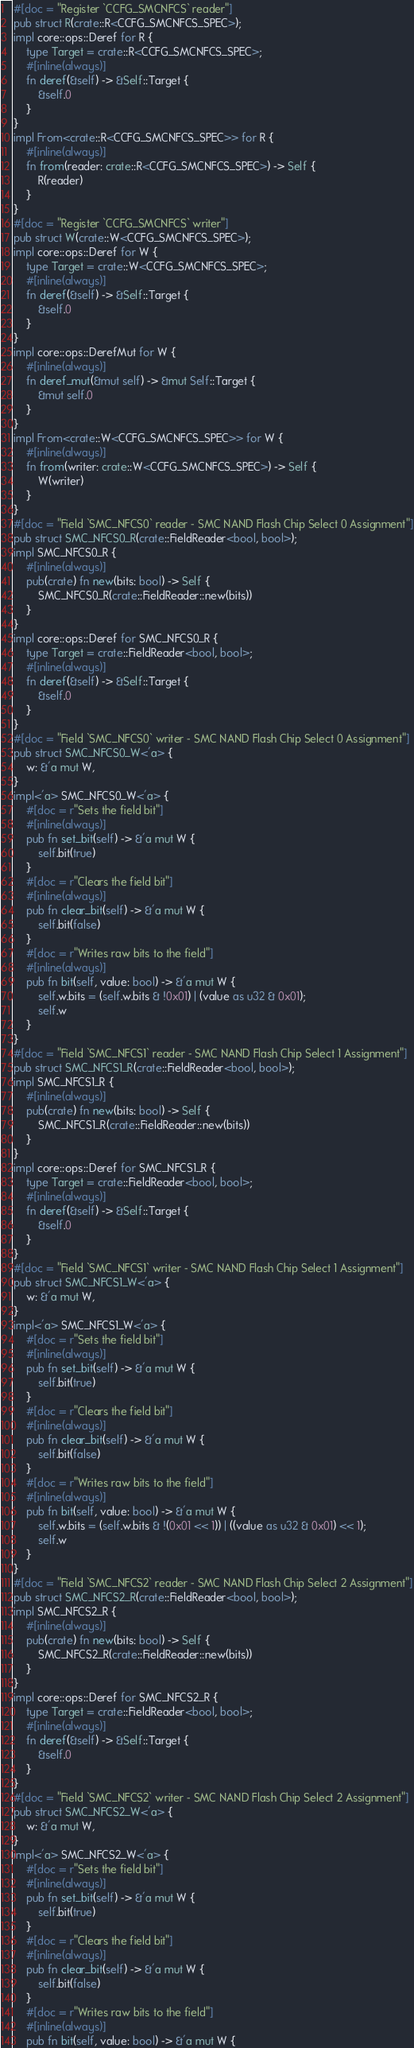<code> <loc_0><loc_0><loc_500><loc_500><_Rust_>#[doc = "Register `CCFG_SMCNFCS` reader"]
pub struct R(crate::R<CCFG_SMCNFCS_SPEC>);
impl core::ops::Deref for R {
    type Target = crate::R<CCFG_SMCNFCS_SPEC>;
    #[inline(always)]
    fn deref(&self) -> &Self::Target {
        &self.0
    }
}
impl From<crate::R<CCFG_SMCNFCS_SPEC>> for R {
    #[inline(always)]
    fn from(reader: crate::R<CCFG_SMCNFCS_SPEC>) -> Self {
        R(reader)
    }
}
#[doc = "Register `CCFG_SMCNFCS` writer"]
pub struct W(crate::W<CCFG_SMCNFCS_SPEC>);
impl core::ops::Deref for W {
    type Target = crate::W<CCFG_SMCNFCS_SPEC>;
    #[inline(always)]
    fn deref(&self) -> &Self::Target {
        &self.0
    }
}
impl core::ops::DerefMut for W {
    #[inline(always)]
    fn deref_mut(&mut self) -> &mut Self::Target {
        &mut self.0
    }
}
impl From<crate::W<CCFG_SMCNFCS_SPEC>> for W {
    #[inline(always)]
    fn from(writer: crate::W<CCFG_SMCNFCS_SPEC>) -> Self {
        W(writer)
    }
}
#[doc = "Field `SMC_NFCS0` reader - SMC NAND Flash Chip Select 0 Assignment"]
pub struct SMC_NFCS0_R(crate::FieldReader<bool, bool>);
impl SMC_NFCS0_R {
    #[inline(always)]
    pub(crate) fn new(bits: bool) -> Self {
        SMC_NFCS0_R(crate::FieldReader::new(bits))
    }
}
impl core::ops::Deref for SMC_NFCS0_R {
    type Target = crate::FieldReader<bool, bool>;
    #[inline(always)]
    fn deref(&self) -> &Self::Target {
        &self.0
    }
}
#[doc = "Field `SMC_NFCS0` writer - SMC NAND Flash Chip Select 0 Assignment"]
pub struct SMC_NFCS0_W<'a> {
    w: &'a mut W,
}
impl<'a> SMC_NFCS0_W<'a> {
    #[doc = r"Sets the field bit"]
    #[inline(always)]
    pub fn set_bit(self) -> &'a mut W {
        self.bit(true)
    }
    #[doc = r"Clears the field bit"]
    #[inline(always)]
    pub fn clear_bit(self) -> &'a mut W {
        self.bit(false)
    }
    #[doc = r"Writes raw bits to the field"]
    #[inline(always)]
    pub fn bit(self, value: bool) -> &'a mut W {
        self.w.bits = (self.w.bits & !0x01) | (value as u32 & 0x01);
        self.w
    }
}
#[doc = "Field `SMC_NFCS1` reader - SMC NAND Flash Chip Select 1 Assignment"]
pub struct SMC_NFCS1_R(crate::FieldReader<bool, bool>);
impl SMC_NFCS1_R {
    #[inline(always)]
    pub(crate) fn new(bits: bool) -> Self {
        SMC_NFCS1_R(crate::FieldReader::new(bits))
    }
}
impl core::ops::Deref for SMC_NFCS1_R {
    type Target = crate::FieldReader<bool, bool>;
    #[inline(always)]
    fn deref(&self) -> &Self::Target {
        &self.0
    }
}
#[doc = "Field `SMC_NFCS1` writer - SMC NAND Flash Chip Select 1 Assignment"]
pub struct SMC_NFCS1_W<'a> {
    w: &'a mut W,
}
impl<'a> SMC_NFCS1_W<'a> {
    #[doc = r"Sets the field bit"]
    #[inline(always)]
    pub fn set_bit(self) -> &'a mut W {
        self.bit(true)
    }
    #[doc = r"Clears the field bit"]
    #[inline(always)]
    pub fn clear_bit(self) -> &'a mut W {
        self.bit(false)
    }
    #[doc = r"Writes raw bits to the field"]
    #[inline(always)]
    pub fn bit(self, value: bool) -> &'a mut W {
        self.w.bits = (self.w.bits & !(0x01 << 1)) | ((value as u32 & 0x01) << 1);
        self.w
    }
}
#[doc = "Field `SMC_NFCS2` reader - SMC NAND Flash Chip Select 2 Assignment"]
pub struct SMC_NFCS2_R(crate::FieldReader<bool, bool>);
impl SMC_NFCS2_R {
    #[inline(always)]
    pub(crate) fn new(bits: bool) -> Self {
        SMC_NFCS2_R(crate::FieldReader::new(bits))
    }
}
impl core::ops::Deref for SMC_NFCS2_R {
    type Target = crate::FieldReader<bool, bool>;
    #[inline(always)]
    fn deref(&self) -> &Self::Target {
        &self.0
    }
}
#[doc = "Field `SMC_NFCS2` writer - SMC NAND Flash Chip Select 2 Assignment"]
pub struct SMC_NFCS2_W<'a> {
    w: &'a mut W,
}
impl<'a> SMC_NFCS2_W<'a> {
    #[doc = r"Sets the field bit"]
    #[inline(always)]
    pub fn set_bit(self) -> &'a mut W {
        self.bit(true)
    }
    #[doc = r"Clears the field bit"]
    #[inline(always)]
    pub fn clear_bit(self) -> &'a mut W {
        self.bit(false)
    }
    #[doc = r"Writes raw bits to the field"]
    #[inline(always)]
    pub fn bit(self, value: bool) -> &'a mut W {</code> 